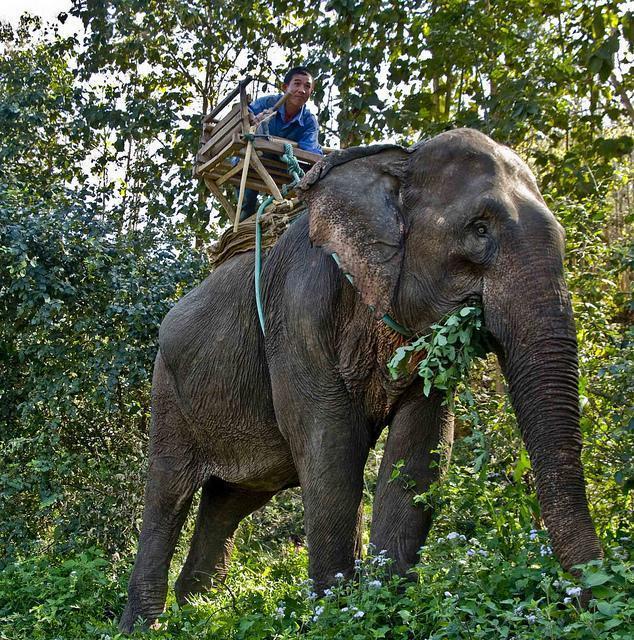How many people are on top of the elephant?
Give a very brief answer. 1. How many purple ties are there?
Give a very brief answer. 0. 